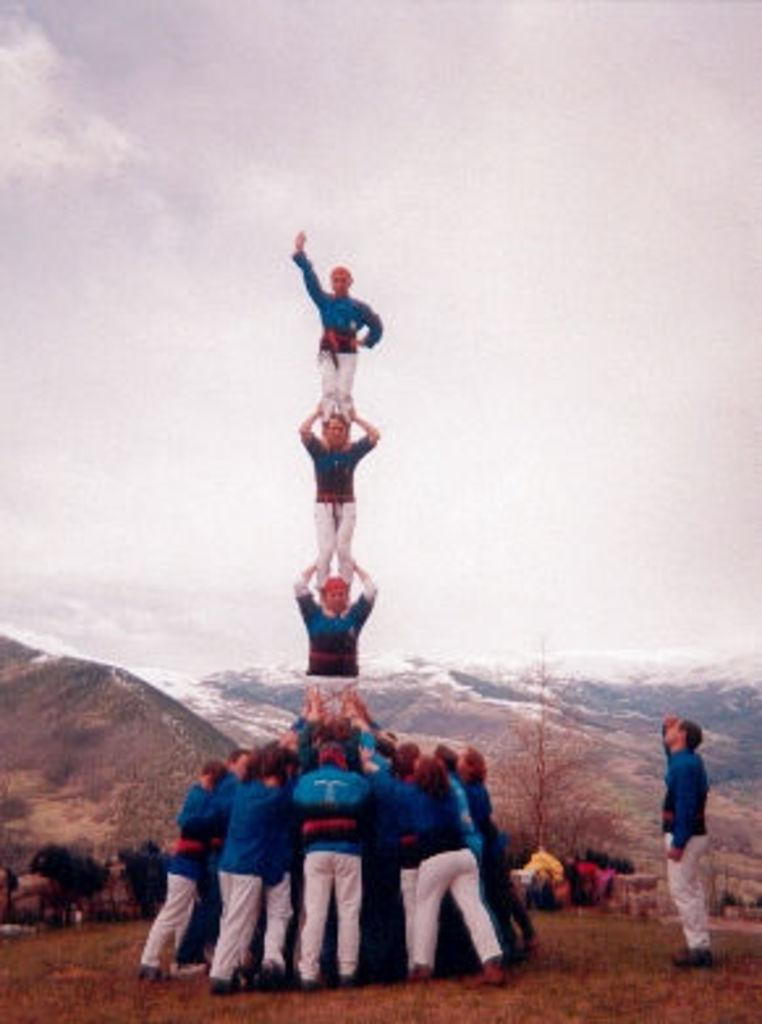How many people are present in the image? There are many people in the image. Can you describe the arrangement of some people in the image? Some people are standing one above the other. What can be seen in the background of the image? There are trees, hills, and the sky visible in the background of the image. Where is the nest located in the image? There is no nest present in the image. What is the slope of the hill in the image? The facts do not provide information about the slope of the hill, only that there are hills in the background. What time of day is depicted in the image? The facts do not provide information about the time of day; only the presence of the sky is mentioned. 